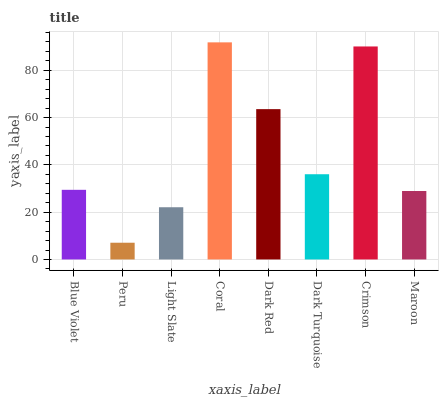Is Peru the minimum?
Answer yes or no. Yes. Is Coral the maximum?
Answer yes or no. Yes. Is Light Slate the minimum?
Answer yes or no. No. Is Light Slate the maximum?
Answer yes or no. No. Is Light Slate greater than Peru?
Answer yes or no. Yes. Is Peru less than Light Slate?
Answer yes or no. Yes. Is Peru greater than Light Slate?
Answer yes or no. No. Is Light Slate less than Peru?
Answer yes or no. No. Is Dark Turquoise the high median?
Answer yes or no. Yes. Is Blue Violet the low median?
Answer yes or no. Yes. Is Maroon the high median?
Answer yes or no. No. Is Dark Turquoise the low median?
Answer yes or no. No. 